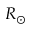<formula> <loc_0><loc_0><loc_500><loc_500>R _ { \odot }</formula> 